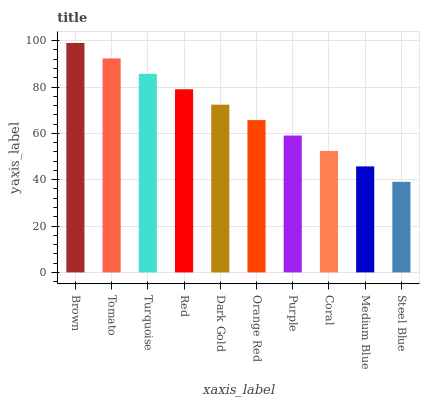Is Tomato the minimum?
Answer yes or no. No. Is Tomato the maximum?
Answer yes or no. No. Is Brown greater than Tomato?
Answer yes or no. Yes. Is Tomato less than Brown?
Answer yes or no. Yes. Is Tomato greater than Brown?
Answer yes or no. No. Is Brown less than Tomato?
Answer yes or no. No. Is Dark Gold the high median?
Answer yes or no. Yes. Is Orange Red the low median?
Answer yes or no. Yes. Is Orange Red the high median?
Answer yes or no. No. Is Medium Blue the low median?
Answer yes or no. No. 